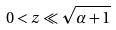<formula> <loc_0><loc_0><loc_500><loc_500>0 < z \ll \sqrt { \alpha + 1 }</formula> 